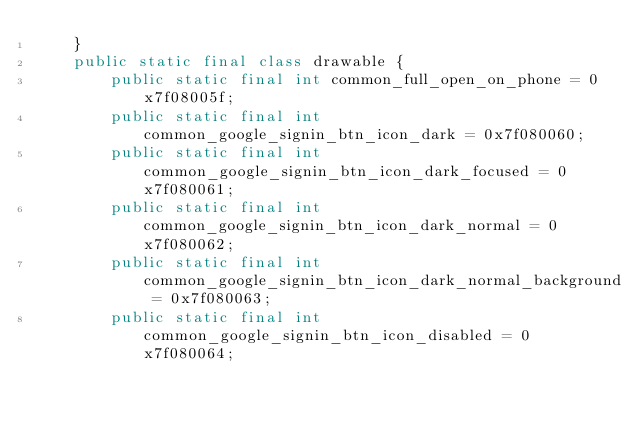Convert code to text. <code><loc_0><loc_0><loc_500><loc_500><_Java_>    }
    public static final class drawable {
        public static final int common_full_open_on_phone = 0x7f08005f;
        public static final int common_google_signin_btn_icon_dark = 0x7f080060;
        public static final int common_google_signin_btn_icon_dark_focused = 0x7f080061;
        public static final int common_google_signin_btn_icon_dark_normal = 0x7f080062;
        public static final int common_google_signin_btn_icon_dark_normal_background = 0x7f080063;
        public static final int common_google_signin_btn_icon_disabled = 0x7f080064;</code> 